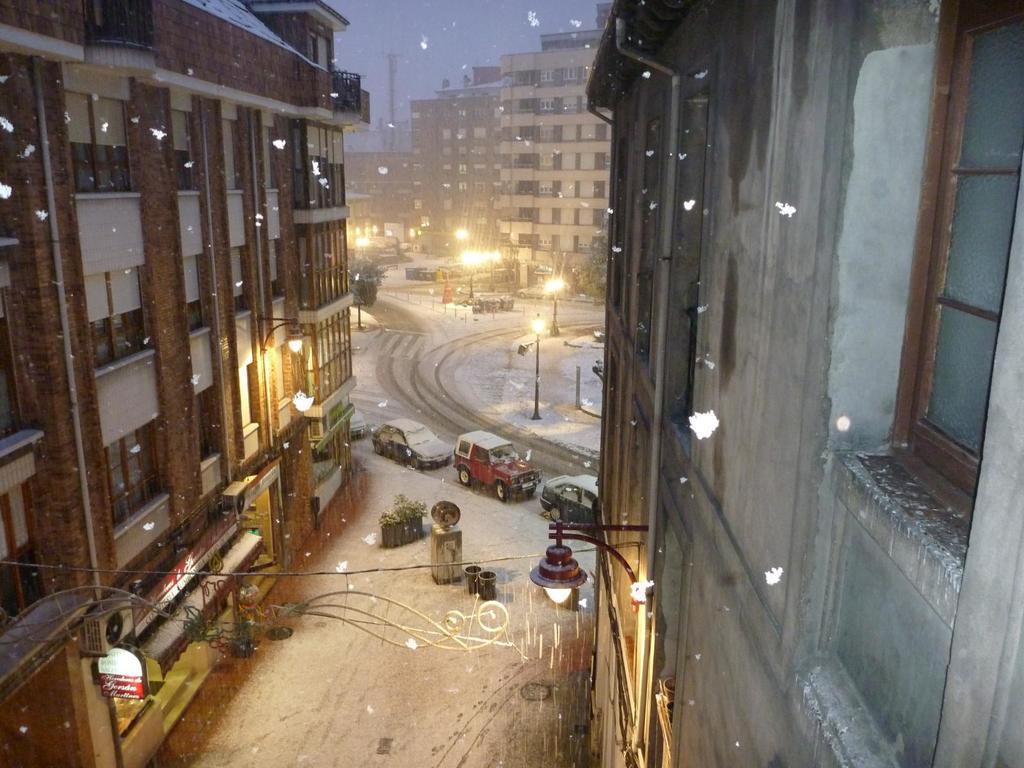In one or two sentences, can you explain what this image depicts? In this image I can see number of buildings, number of poles, number of lights and on the bottom left side of the image I can see two boards. On these words I can see something is written. In the centre of the image I can see few vehicles and few other things on the ground. On the top side of the image I can see the sky. 